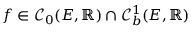<formula> <loc_0><loc_0><loc_500><loc_500>f \in \mathcal { C } _ { 0 } ( E , \mathbb { R } ) \cap \mathcal { C } _ { b } ^ { 1 } ( E , \mathbb { R } )</formula> 